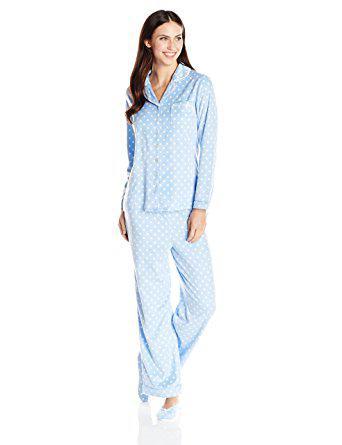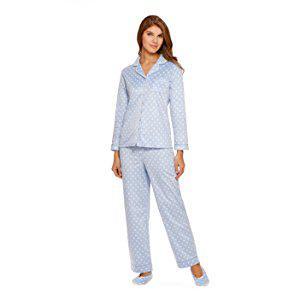The first image is the image on the left, the second image is the image on the right. Analyze the images presented: Is the assertion "Each model wears printed pajamas, and each pajama outfit includes a button-up top with a shirt collar." valid? Answer yes or no. Yes. The first image is the image on the left, the second image is the image on the right. Assess this claim about the two images: "Both models are wearing the same design of pajamas.". Correct or not? Answer yes or no. Yes. 